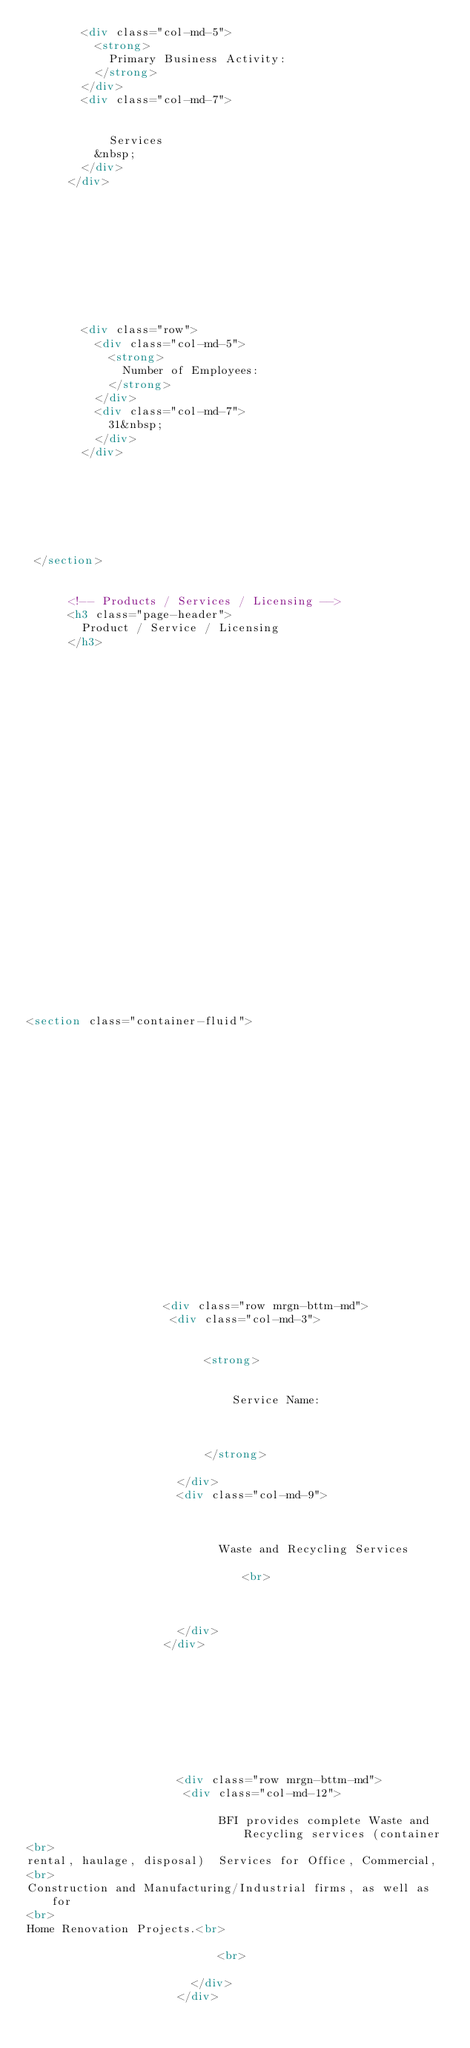Convert code to text. <code><loc_0><loc_0><loc_500><loc_500><_HTML_>        <div class="col-md-5">
          <strong>
            Primary Business Activity:
          </strong>
        </div>
        <div class="col-md-7">
          
            
            Services
          &nbsp;   
        </div>
      </div>  
          
    
            

    
      
                  
  
    
      
        <div class="row">
          <div class="col-md-5">
            <strong>
              Number of Employees:
            </strong>
          </div>
          <div class="col-md-7">
            31&nbsp;
          </div>
        </div>    
      
    

    
    
 
 
 </section>
 

			<!-- Products / Services / Licensing -->
			<h3 class="page-header">
				Product / Service / Licensing
			</h3>
			 















  
    
      
        
          
        
      
       
  


<section class="container-fluid">


      
    
            
        
      
          
            	                     
              
            
          
        
      
          
            	                     
              
                
                  

                    <div class="row mrgn-bttm-md">
                     <div class="col-md-3">
                        

                          <strong>
                            
                            
                              Service Name:
                            
                            
                                                                                              
                          </strong>
                        
                      </div>
                      <div class="col-md-9">
                        
                      
                          
                            Waste and Recycling Services                                                                                                                          <br>
                          
                        
                        
                      </div>
                    </div>
                  
                

               

                
  
                  
                    
                      <div class="row mrgn-bttm-md">
                       <div class="col-md-12">
                          
                            BFI provides complete Waste and Recycling services (container <br>
rental, haulage, disposal)  Services for Office, Commercial, <br>
Construction and Manufacturing/Industrial firms, as well as for <br>
Home Renovation Projects.<br>
                            
                            <br>
                          
                        </div>
                      </div>
                    
                  
                
                
              
            
          
        
      
          
            	                     
              
            
          
        
      
          </code> 